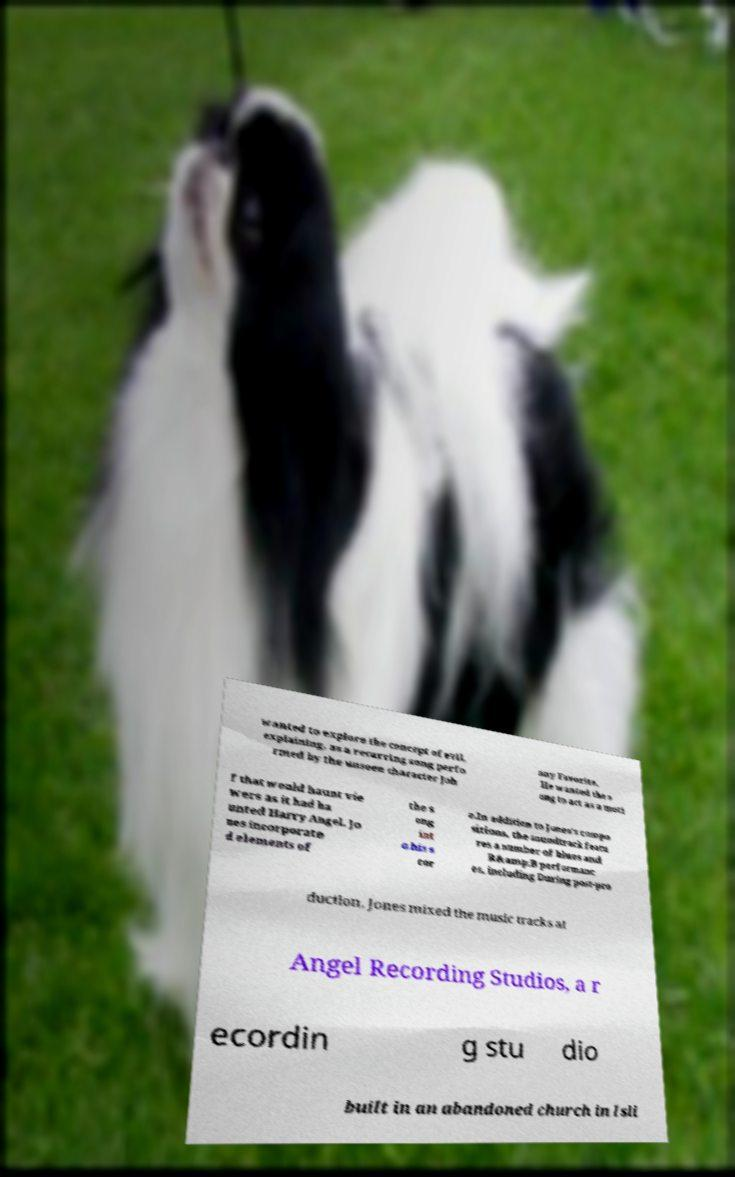I need the written content from this picture converted into text. Can you do that? wanted to explore the concept of evil, explaining, as a recurring song perfo rmed by the unseen character Joh nny Favorite. He wanted the s ong to act as a moti f that would haunt vie wers as it had ha unted Harry Angel. Jo nes incorporate d elements of the s ong int o his s cor e.In addition to Jones's compo sitions, the soundtrack featu res a number of blues and R&amp;B performanc es, including During post-pro duction, Jones mixed the music tracks at Angel Recording Studios, a r ecordin g stu dio built in an abandoned church in Isli 